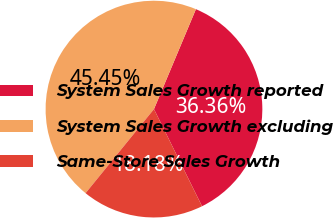Convert chart. <chart><loc_0><loc_0><loc_500><loc_500><pie_chart><fcel>System Sales Growth reported<fcel>System Sales Growth excluding<fcel>Same-Store Sales Growth<nl><fcel>36.36%<fcel>45.45%<fcel>18.18%<nl></chart> 